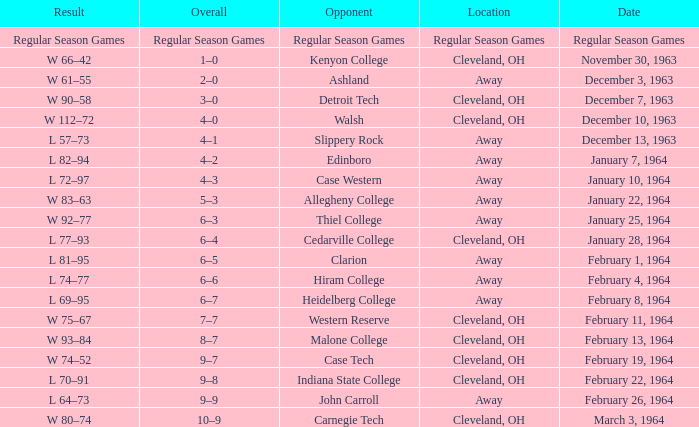What is the Date with an Opponent that is indiana state college? February 22, 1964. 